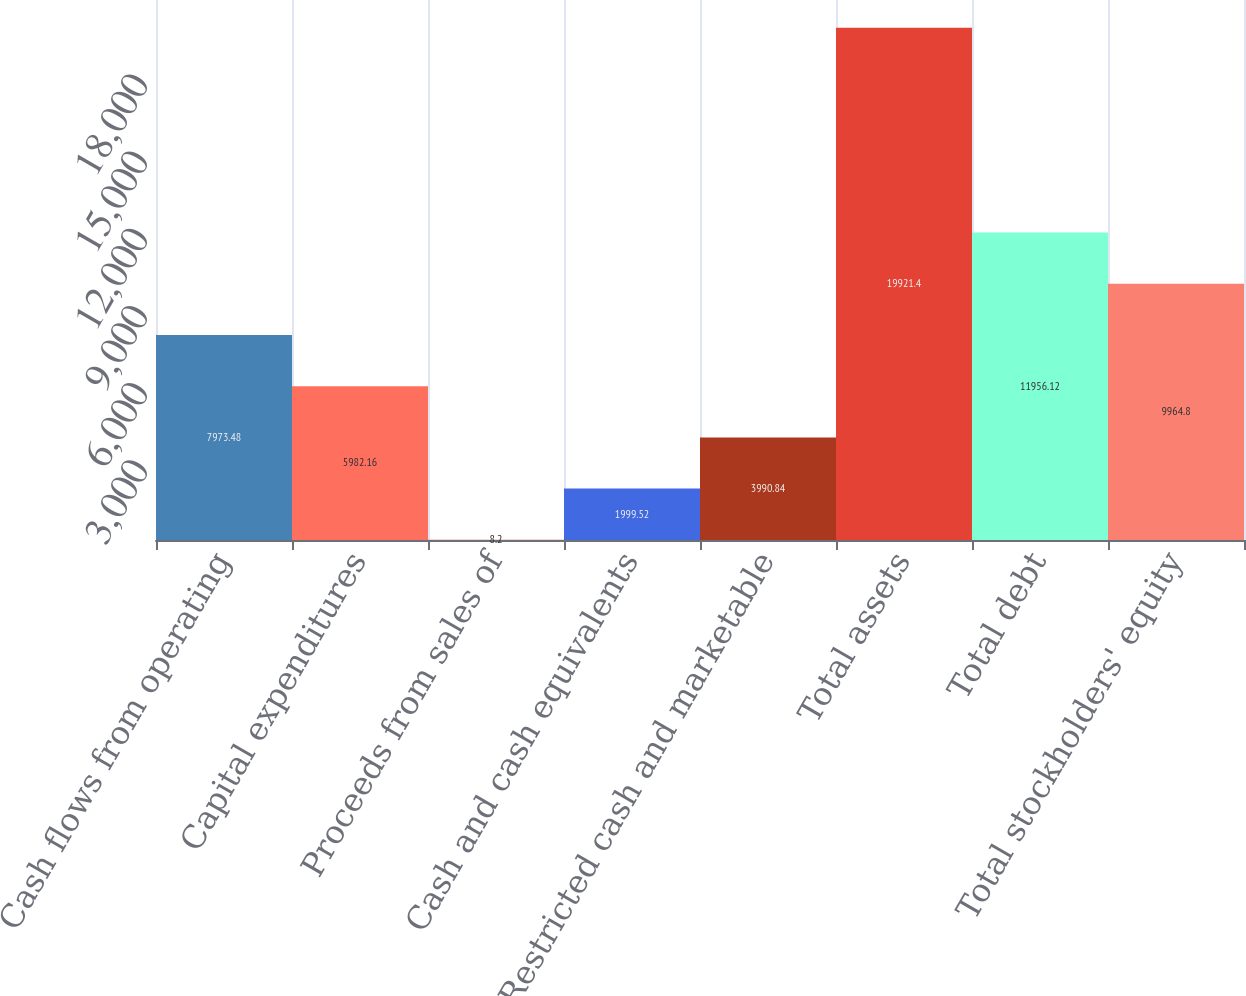<chart> <loc_0><loc_0><loc_500><loc_500><bar_chart><fcel>Cash flows from operating<fcel>Capital expenditures<fcel>Proceeds from sales of<fcel>Cash and cash equivalents<fcel>Restricted cash and marketable<fcel>Total assets<fcel>Total debt<fcel>Total stockholders' equity<nl><fcel>7973.48<fcel>5982.16<fcel>8.2<fcel>1999.52<fcel>3990.84<fcel>19921.4<fcel>11956.1<fcel>9964.8<nl></chart> 